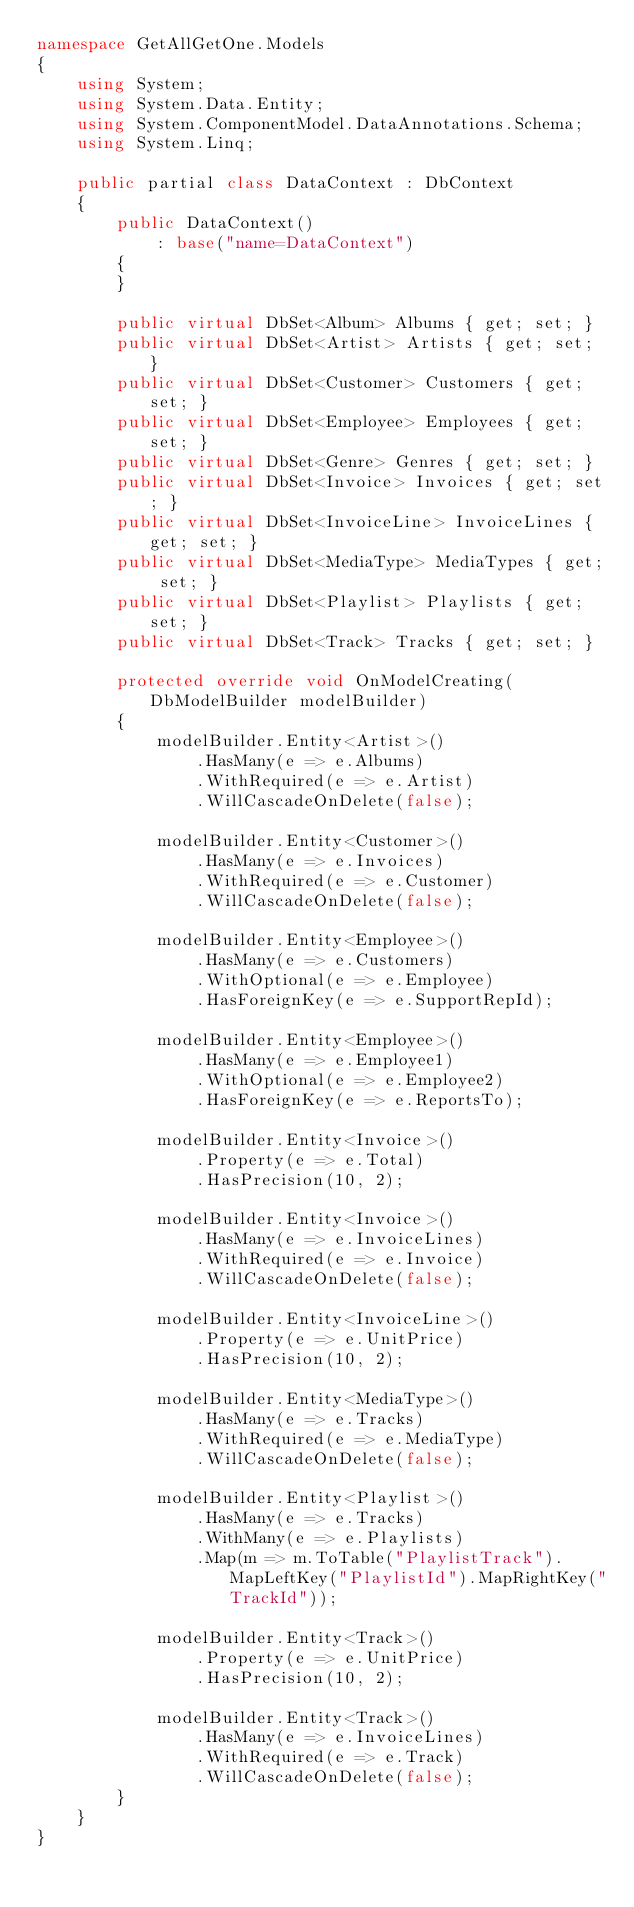Convert code to text. <code><loc_0><loc_0><loc_500><loc_500><_C#_>namespace GetAllGetOne.Models
{
    using System;
    using System.Data.Entity;
    using System.ComponentModel.DataAnnotations.Schema;
    using System.Linq;

    public partial class DataContext : DbContext
    {
        public DataContext()
            : base("name=DataContext")
        {
        }

        public virtual DbSet<Album> Albums { get; set; }
        public virtual DbSet<Artist> Artists { get; set; }
        public virtual DbSet<Customer> Customers { get; set; }
        public virtual DbSet<Employee> Employees { get; set; }
        public virtual DbSet<Genre> Genres { get; set; }
        public virtual DbSet<Invoice> Invoices { get; set; }
        public virtual DbSet<InvoiceLine> InvoiceLines { get; set; }
        public virtual DbSet<MediaType> MediaTypes { get; set; }
        public virtual DbSet<Playlist> Playlists { get; set; }
        public virtual DbSet<Track> Tracks { get; set; }

        protected override void OnModelCreating(DbModelBuilder modelBuilder)
        {
            modelBuilder.Entity<Artist>()
                .HasMany(e => e.Albums)
                .WithRequired(e => e.Artist)
                .WillCascadeOnDelete(false);

            modelBuilder.Entity<Customer>()
                .HasMany(e => e.Invoices)
                .WithRequired(e => e.Customer)
                .WillCascadeOnDelete(false);

            modelBuilder.Entity<Employee>()
                .HasMany(e => e.Customers)
                .WithOptional(e => e.Employee)
                .HasForeignKey(e => e.SupportRepId);

            modelBuilder.Entity<Employee>()
                .HasMany(e => e.Employee1)
                .WithOptional(e => e.Employee2)
                .HasForeignKey(e => e.ReportsTo);

            modelBuilder.Entity<Invoice>()
                .Property(e => e.Total)
                .HasPrecision(10, 2);

            modelBuilder.Entity<Invoice>()
                .HasMany(e => e.InvoiceLines)
                .WithRequired(e => e.Invoice)
                .WillCascadeOnDelete(false);

            modelBuilder.Entity<InvoiceLine>()
                .Property(e => e.UnitPrice)
                .HasPrecision(10, 2);

            modelBuilder.Entity<MediaType>()
                .HasMany(e => e.Tracks)
                .WithRequired(e => e.MediaType)
                .WillCascadeOnDelete(false);

            modelBuilder.Entity<Playlist>()
                .HasMany(e => e.Tracks)
                .WithMany(e => e.Playlists)
                .Map(m => m.ToTable("PlaylistTrack").MapLeftKey("PlaylistId").MapRightKey("TrackId"));

            modelBuilder.Entity<Track>()
                .Property(e => e.UnitPrice)
                .HasPrecision(10, 2);

            modelBuilder.Entity<Track>()
                .HasMany(e => e.InvoiceLines)
                .WithRequired(e => e.Track)
                .WillCascadeOnDelete(false);
        }
    }
}
</code> 